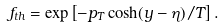Convert formula to latex. <formula><loc_0><loc_0><loc_500><loc_500>f _ { t h } = \exp \left [ - p _ { T } \cosh ( y - \eta ) / T \right ] .</formula> 